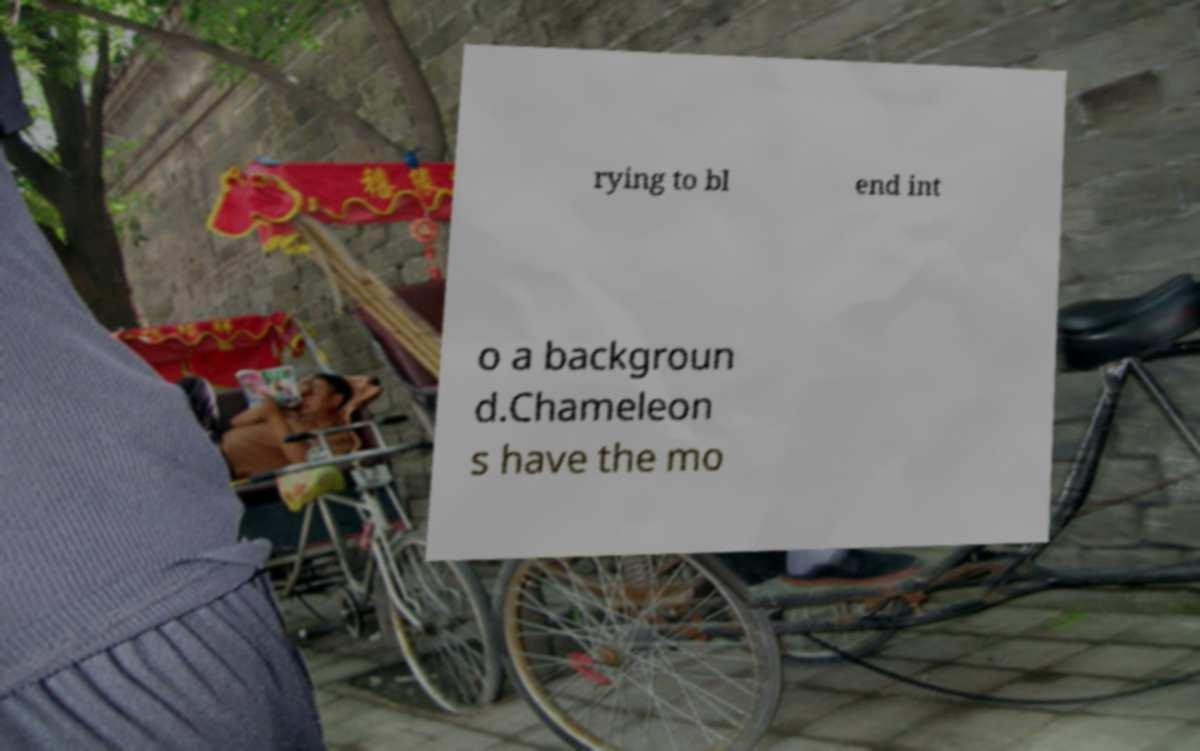Could you extract and type out the text from this image? rying to bl end int o a backgroun d.Chameleon s have the mo 